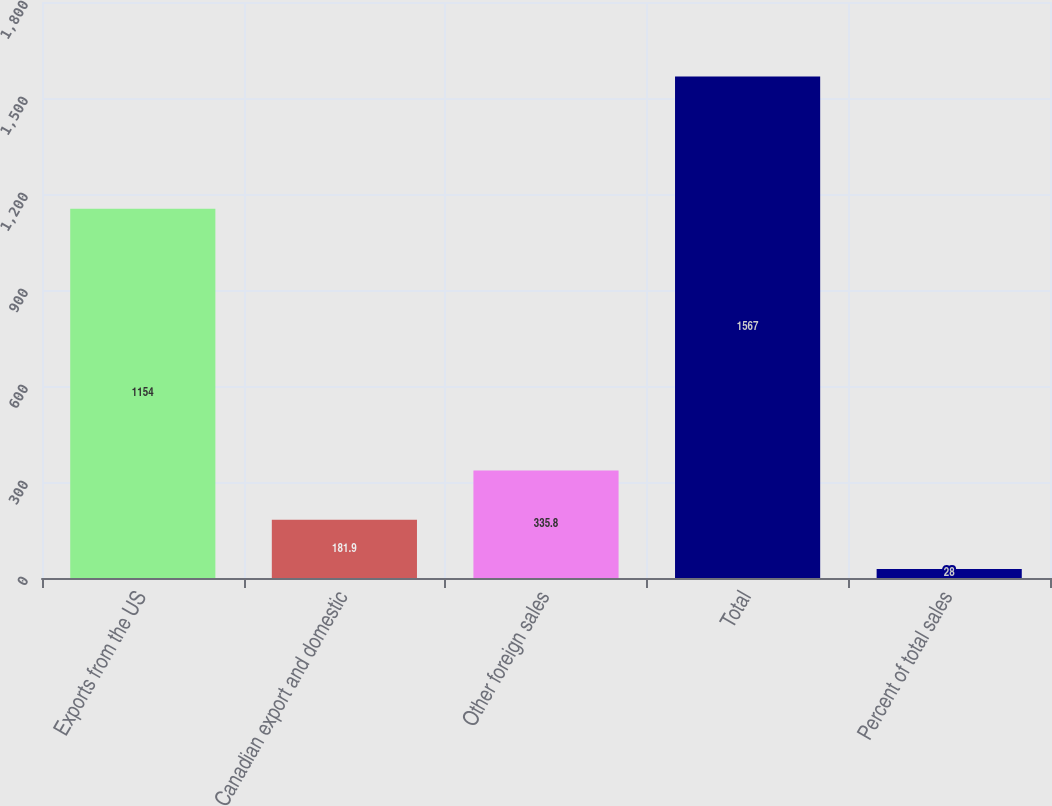Convert chart to OTSL. <chart><loc_0><loc_0><loc_500><loc_500><bar_chart><fcel>Exports from the US<fcel>Canadian export and domestic<fcel>Other foreign sales<fcel>Total<fcel>Percent of total sales<nl><fcel>1154<fcel>181.9<fcel>335.8<fcel>1567<fcel>28<nl></chart> 